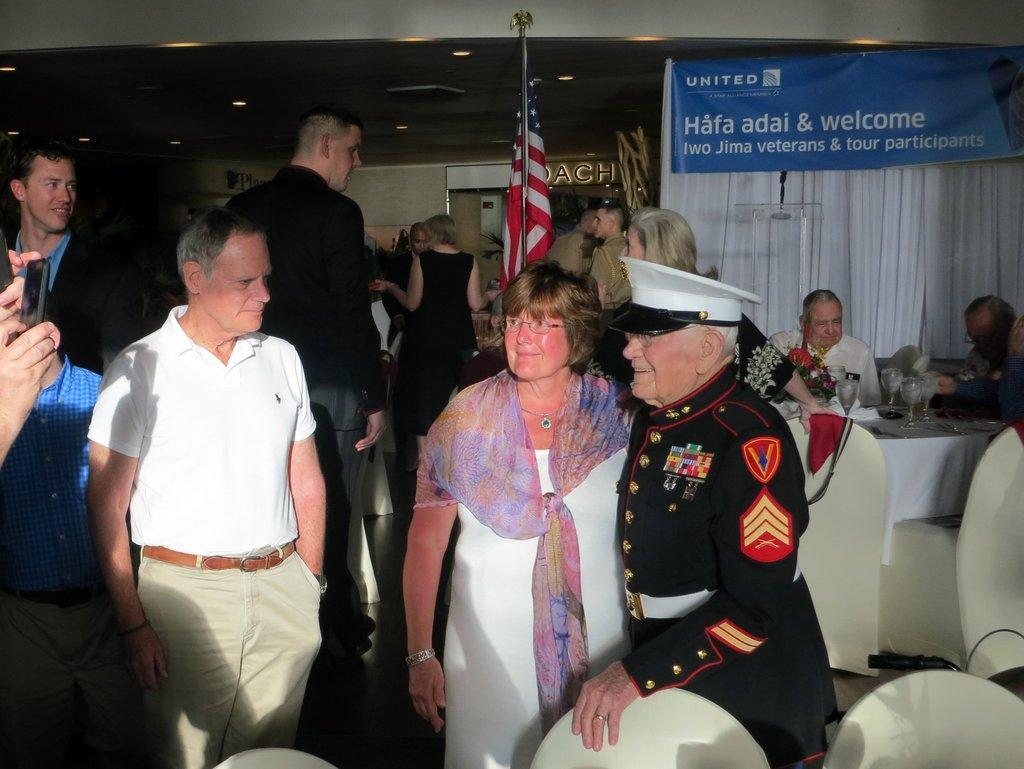How would you summarize this image in a sentence or two? In this image there are group of persons sitting and standing. In the center there is a flag and there is a curtain which is white in colour. On the top of the curtain there is a banner with some text written on it which is blue in colour. In the front there is a man standing wearing a black colour dress and a white colour hat is smiling and the woman standing beside the man is smiling. On the left side there is a hand of the person holding a mobile phone which is visible. 